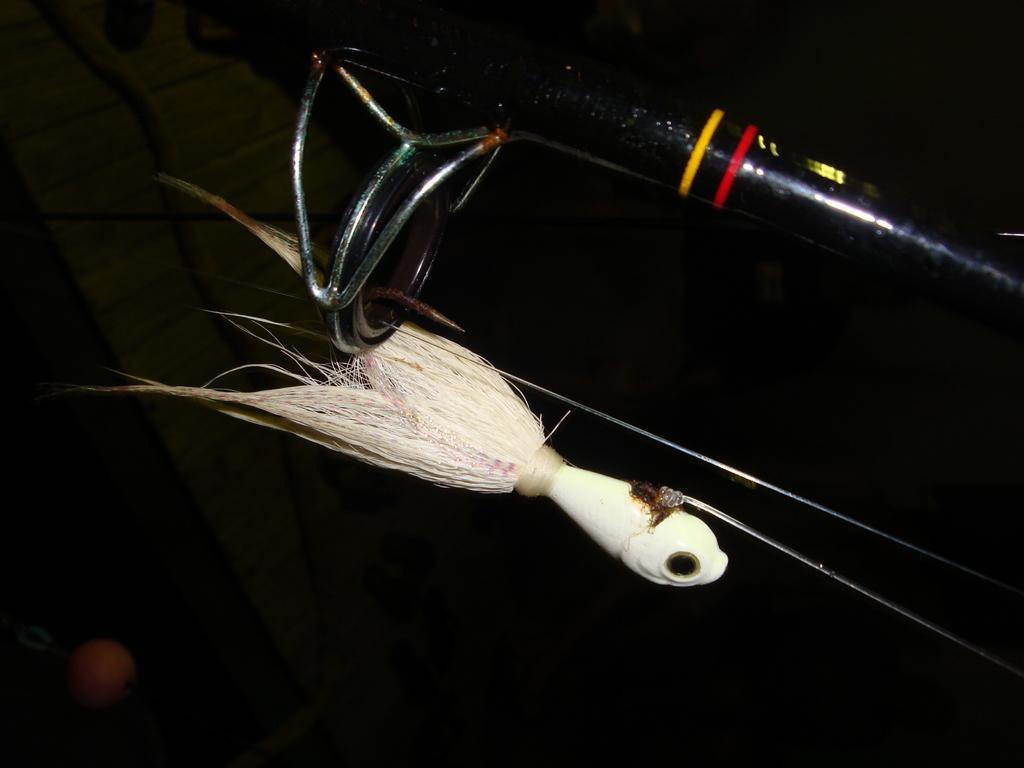Could you give a brief overview of what you see in this image? In this image I can see a bird toy kept on stand and background is dark view. 